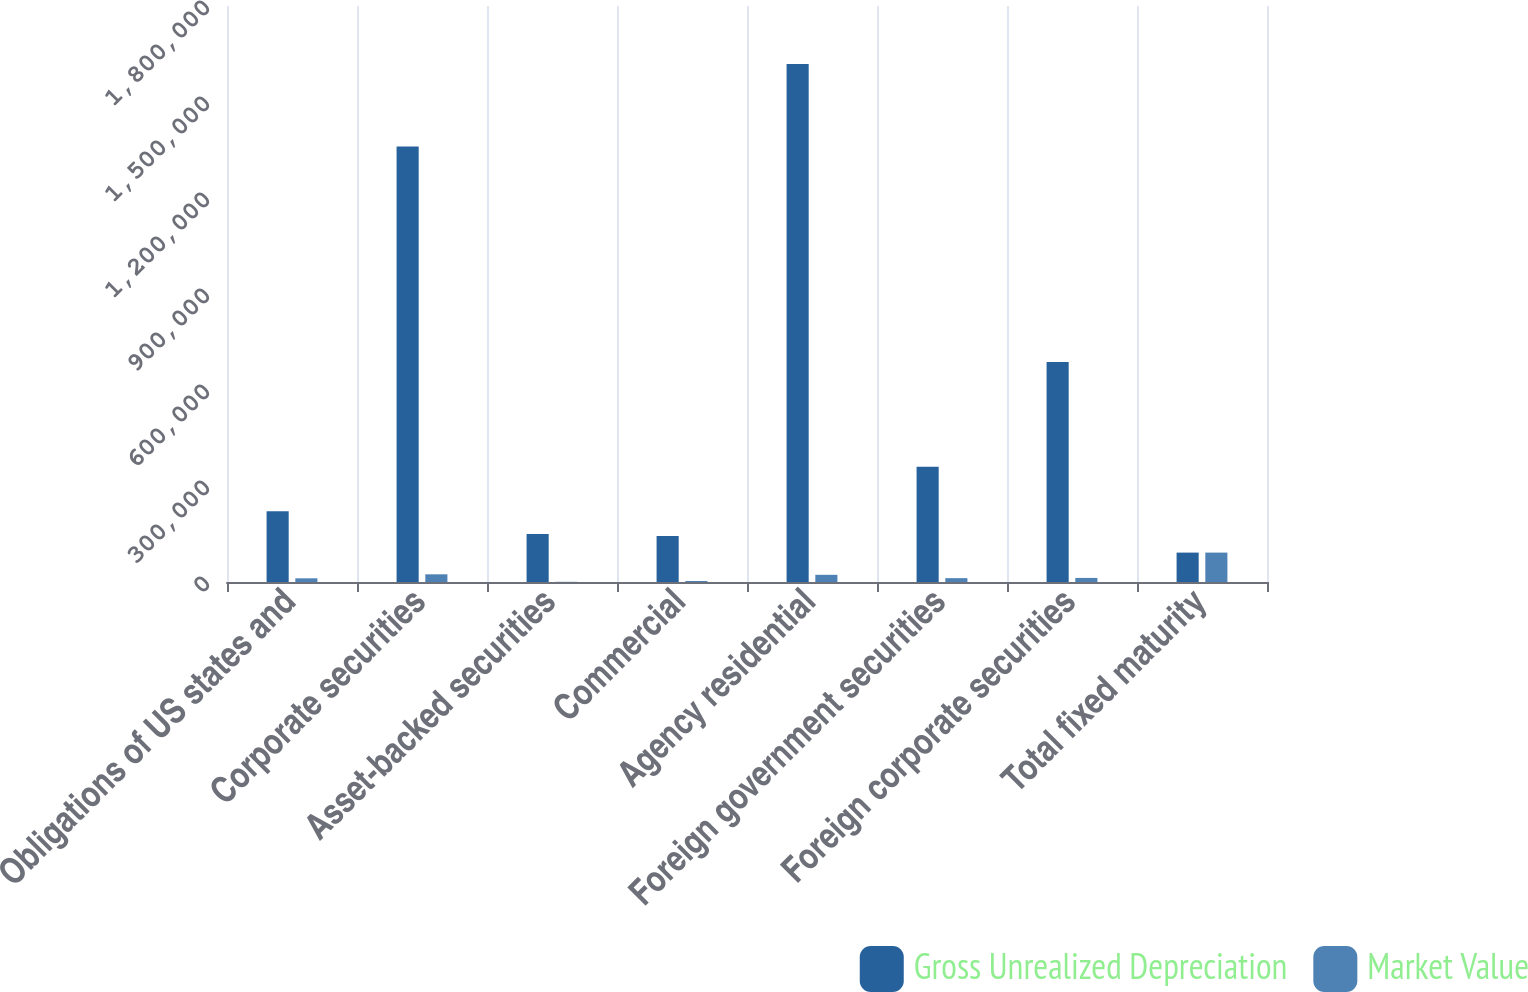Convert chart to OTSL. <chart><loc_0><loc_0><loc_500><loc_500><stacked_bar_chart><ecel><fcel>Obligations of US states and<fcel>Corporate securities<fcel>Asset-backed securities<fcel>Commercial<fcel>Agency residential<fcel>Foreign government securities<fcel>Foreign corporate securities<fcel>Total fixed maturity<nl><fcel>Gross Unrealized Depreciation<fcel>221088<fcel>1.36074e+06<fcel>150023<fcel>143554<fcel>1.61837e+06<fcel>360289<fcel>687599<fcel>91871<nl><fcel>Market Value<fcel>11486<fcel>24023<fcel>565<fcel>3223<fcel>22461<fcel>12041<fcel>12769<fcel>91871<nl></chart> 